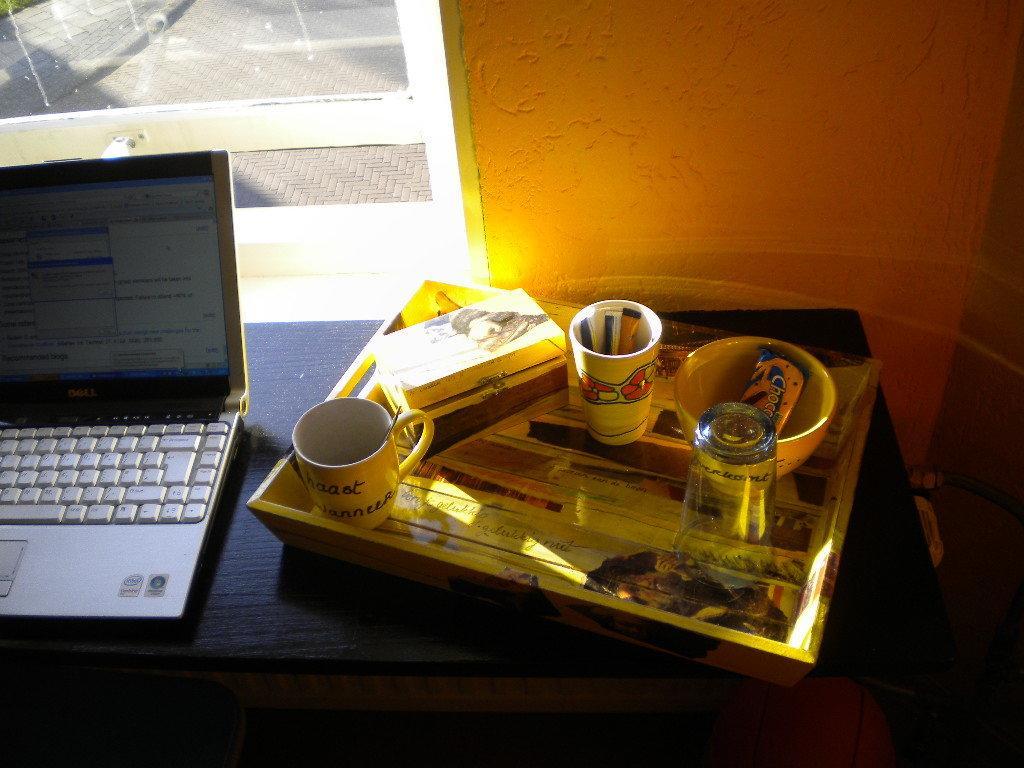Please provide a concise description of this image. In this image there is a table and we can see a laptop, tray, glasses, mug, bowl and a box placed on the table. In the background there is a wall and we can see a window. 